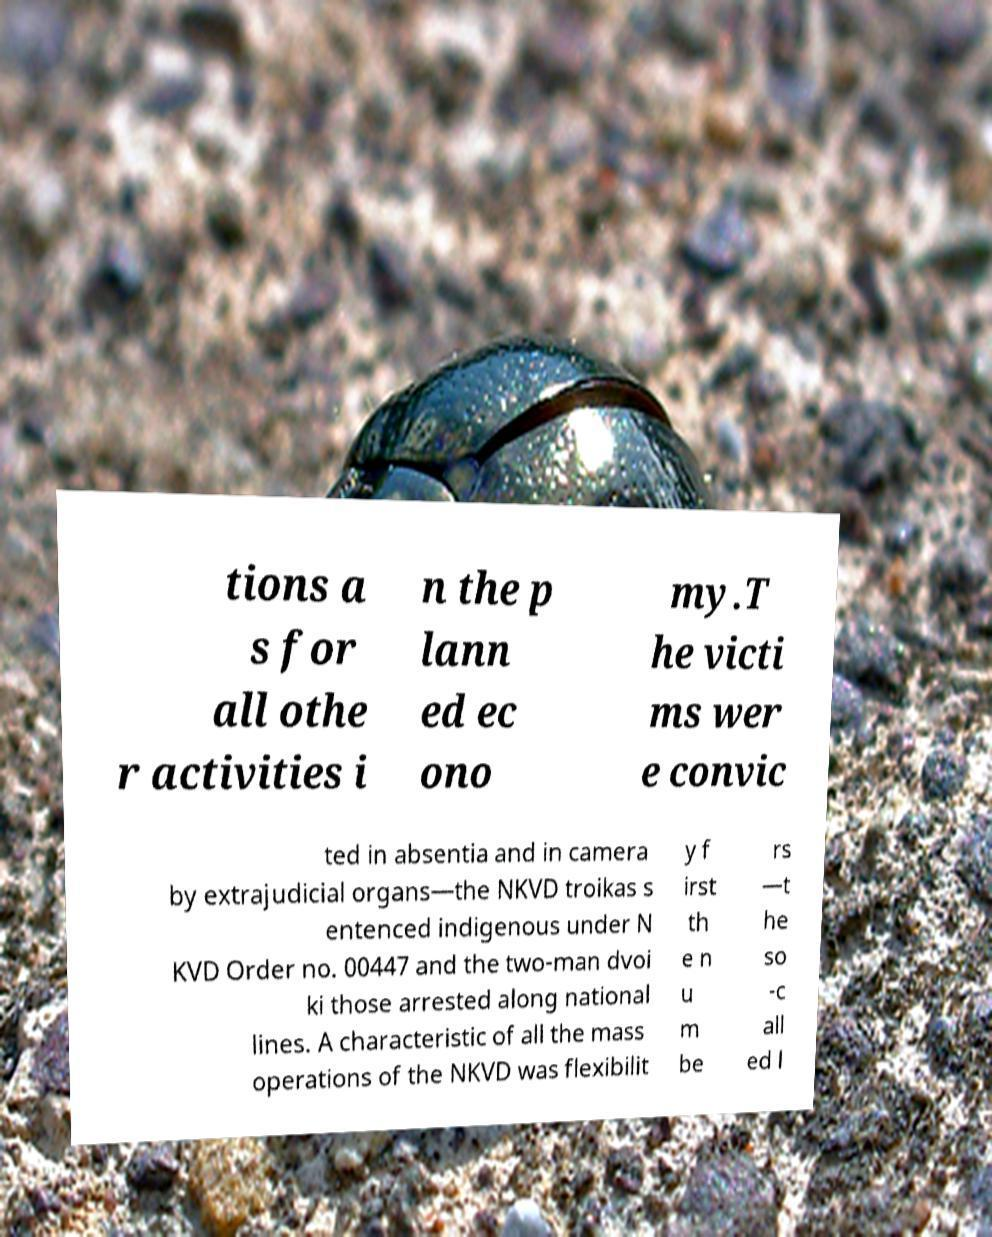Please read and relay the text visible in this image. What does it say? tions a s for all othe r activities i n the p lann ed ec ono my.T he victi ms wer e convic ted in absentia and in camera by extrajudicial organs—the NKVD troikas s entenced indigenous under N KVD Order no. 00447 and the two-man dvoi ki those arrested along national lines. A characteristic of all the mass operations of the NKVD was flexibilit y f irst th e n u m be rs —t he so -c all ed l 